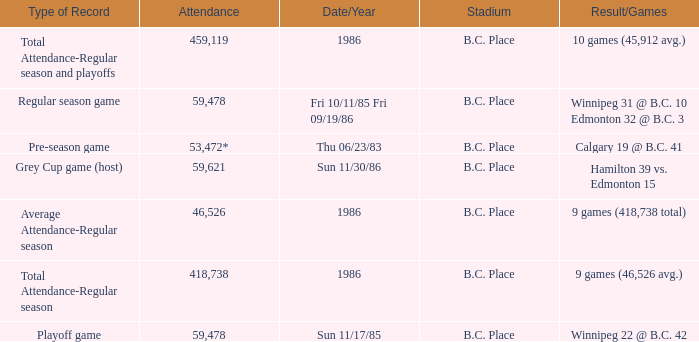What was the stadium that had the regular season game? B.C. Place. 